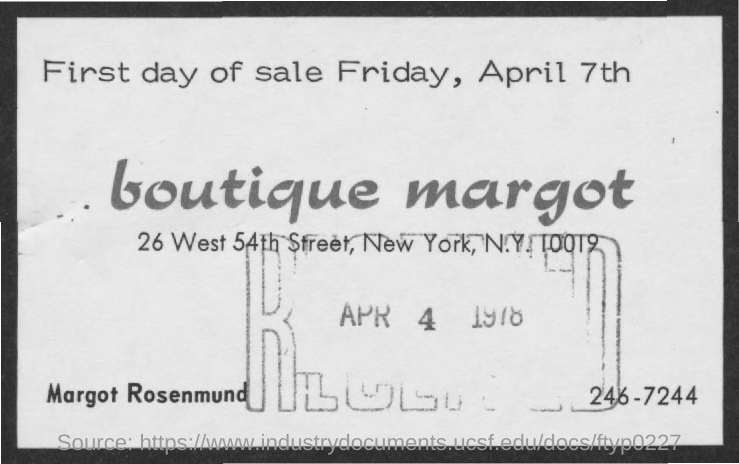When is the first day of sale ?
Ensure brevity in your answer.  Friday, April 7th. In which city it is located ?
Keep it short and to the point. New York. What is the name of the boutique
Offer a terse response. Boutique Margot. 